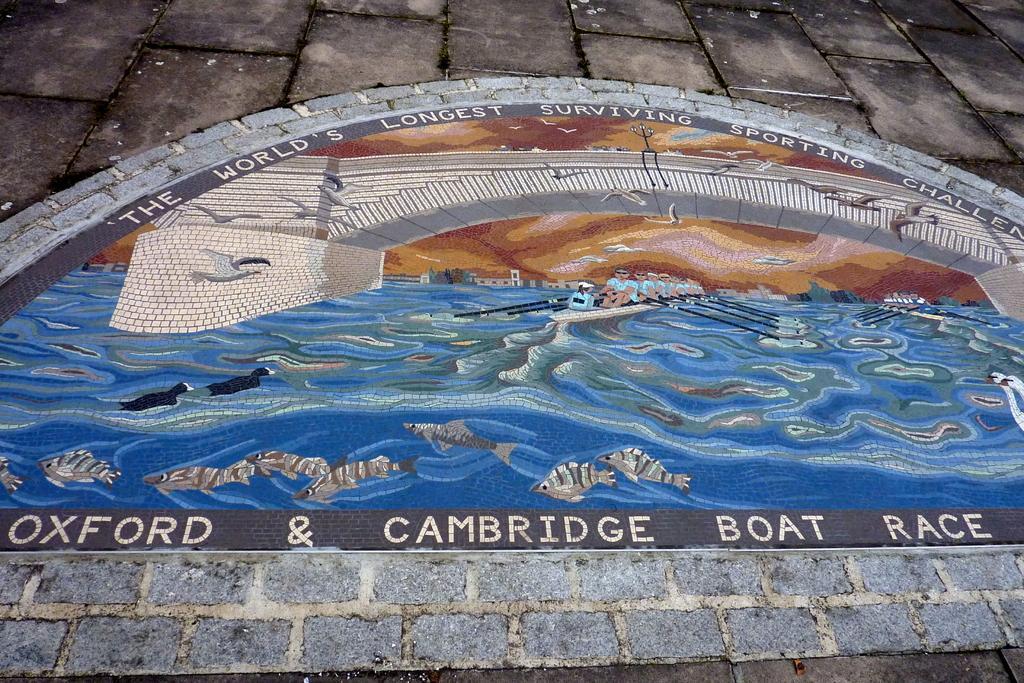Describe this image in one or two sentences. In the middle of this image, there is a painting on a surface. In this painting, we can see there are persons in the boats. These boats on the water. Above them, there are birds flying in the air and there is a bridge. There are fish in the water and there are texts. And the background of this image is gray in color. 